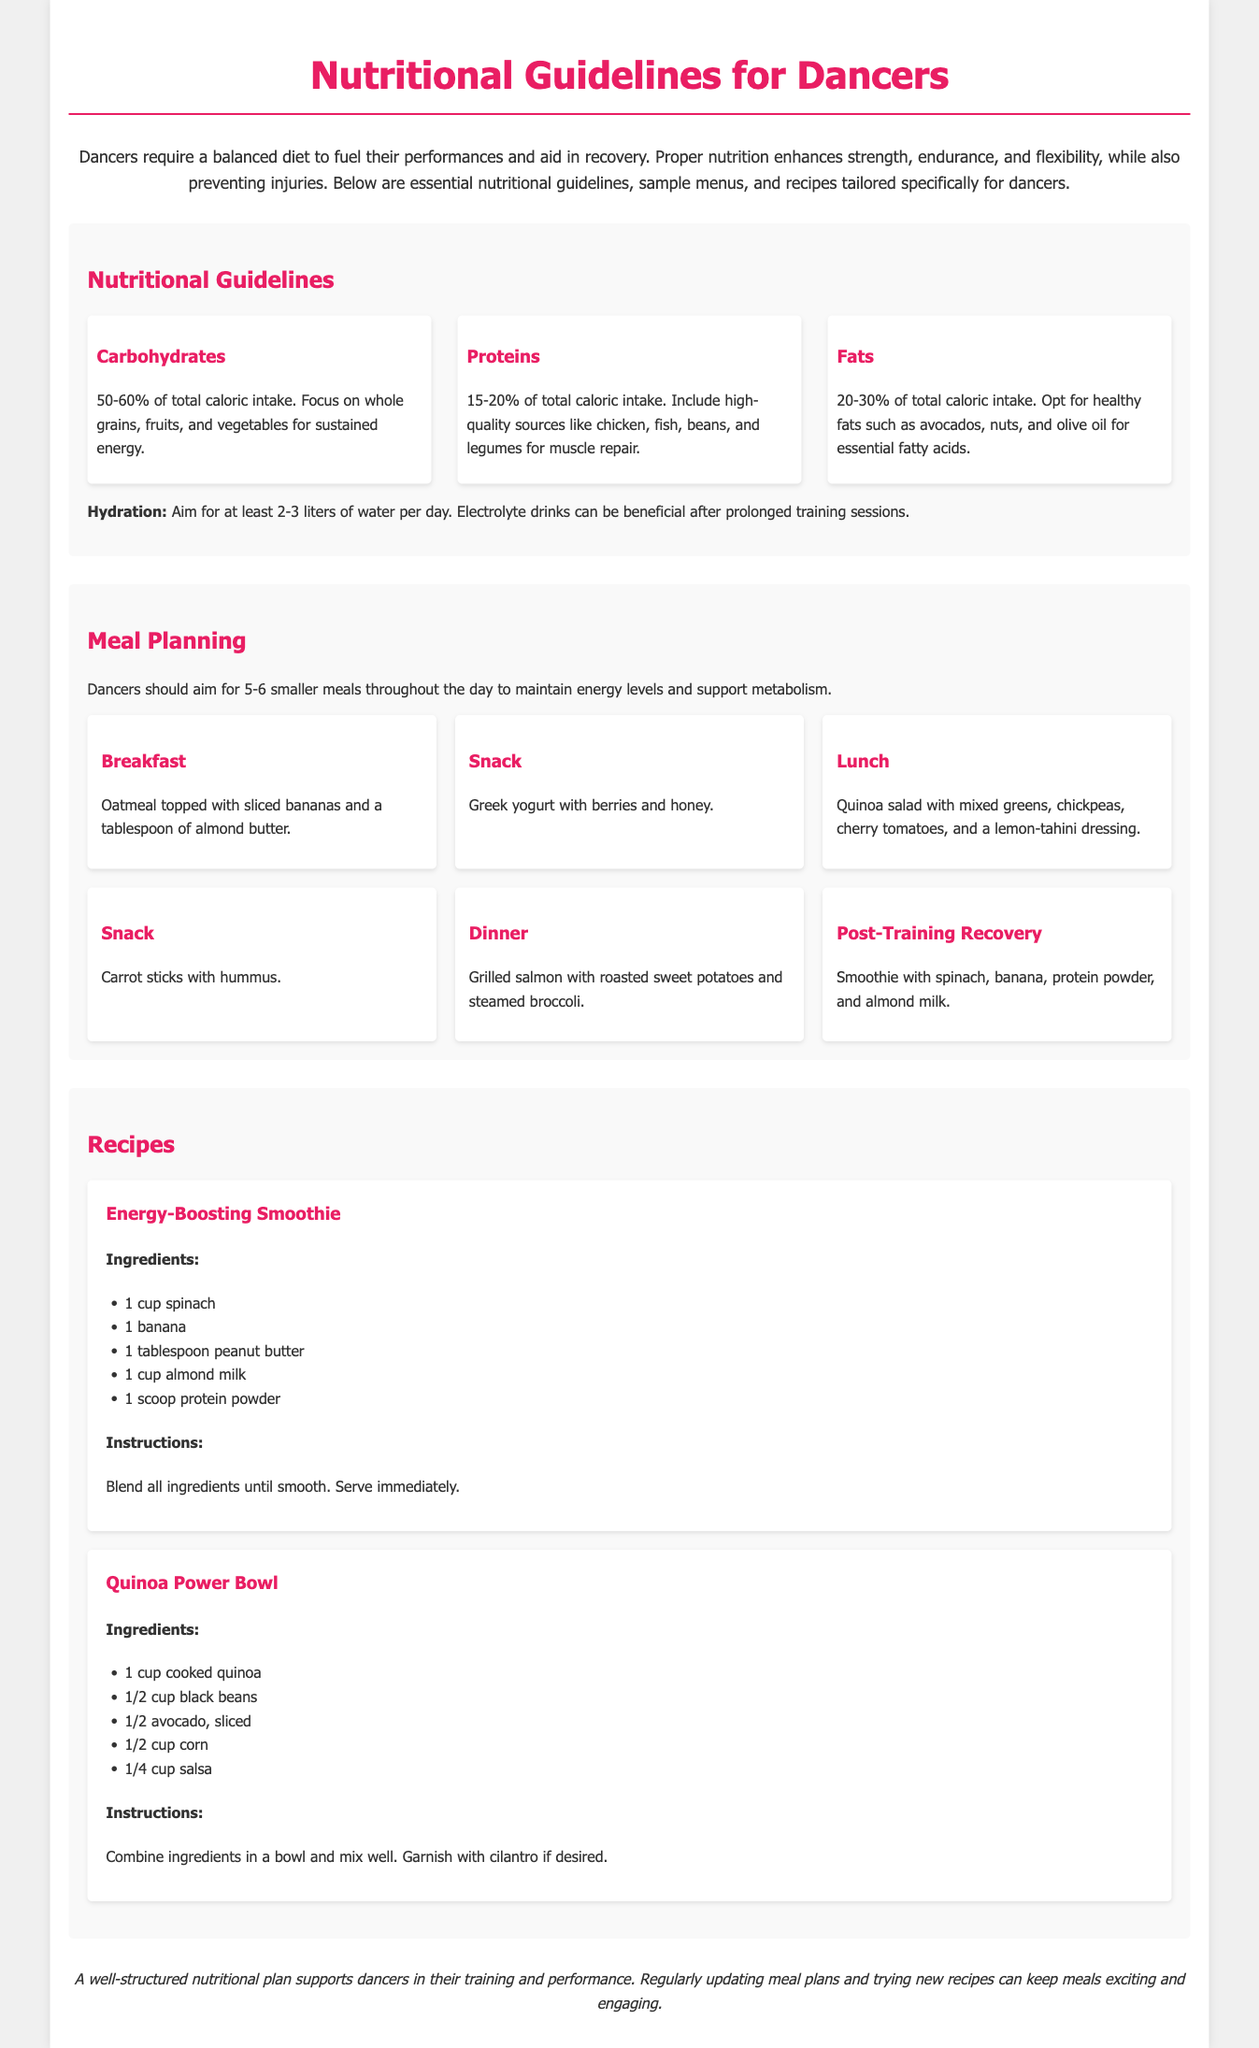What percentage of total caloric intake should come from carbohydrates? The document states that carbohydrates should make up 50-60% of total caloric intake.
Answer: 50-60% What are two high-quality sources of protein mentioned? The document lists chicken, fish, beans, and legumes as high-quality protein sources.
Answer: Chicken, fish What should dancers aim for in terms of hydration? According to the guidelines, dancers should aim for at least 2-3 liters of water per day.
Answer: 2-3 liters What is included in the post-training recovery meal? The document states that the post-training recovery meal consists of a smoothie with spinach, banana, protein powder, and almond milk.
Answer: Smoothie How many meals should dancers aim for throughout the day? It is recommended that dancers aim for 5-6 smaller meals throughout the day.
Answer: 5-6 What is the main ingredient of the Energy-Boosting Smoothie? The main ingredient of the Energy-Boosting Smoothie is spinach.
Answer: Spinach What recipe is provided for a power bowl? The document includes the recipe for a Quinoa Power Bowl.
Answer: Quinoa Power Bowl What type of fats should dancers opt for? The guidelines suggest opting for healthy fats such as avocados, nuts, and olive oil.
Answer: Healthy fats What is the focus of the meal planning section? The meal planning section emphasizes maintaining energy levels and supporting metabolism.
Answer: Energy levels and metabolism 